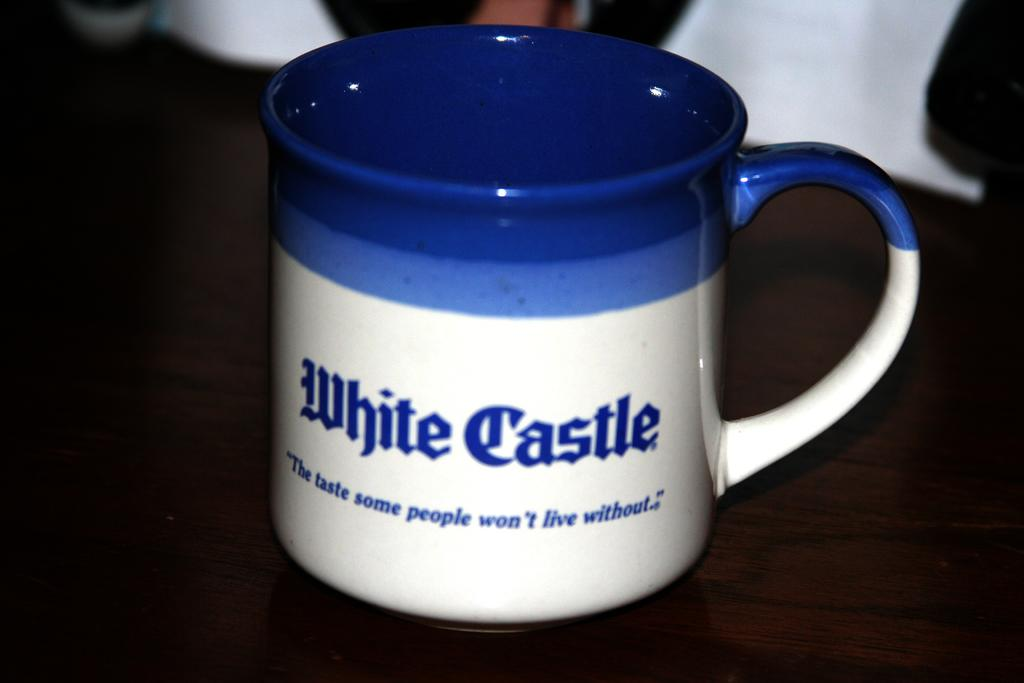<image>
Provide a brief description of the given image. A blue and white coffee mug with the words White Castle on it and the quote" The tast some people won't live without" 